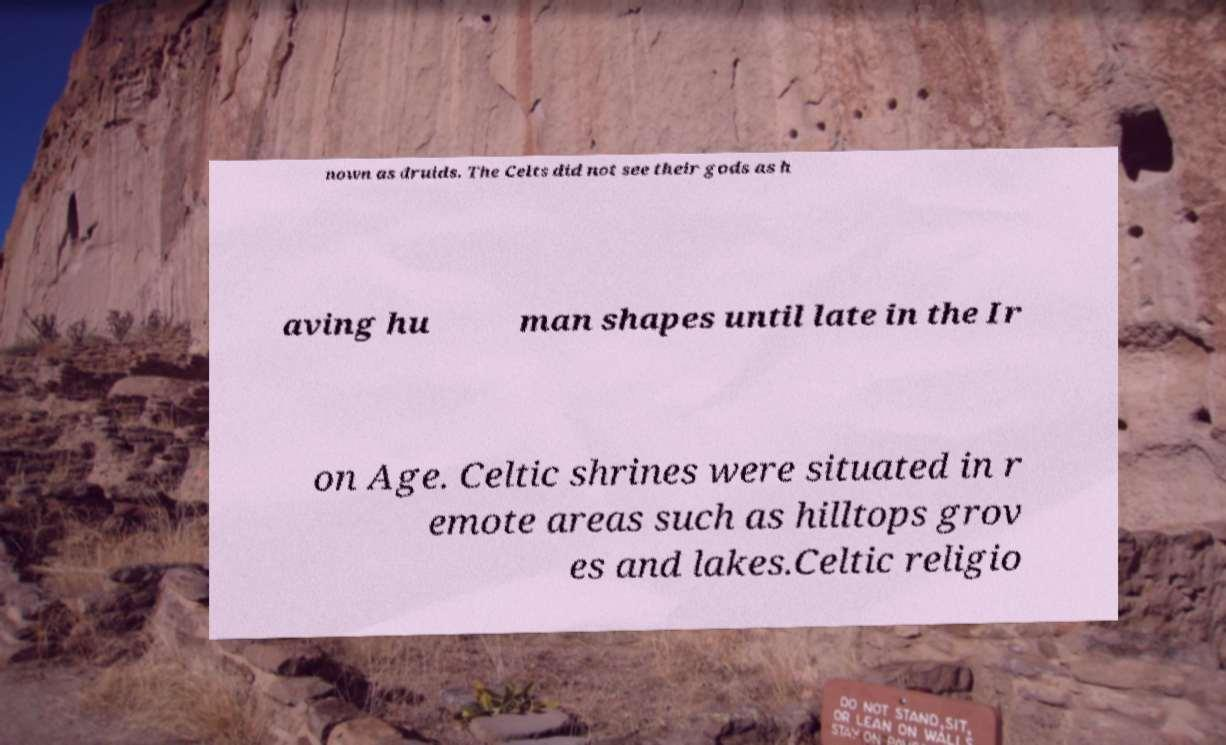For documentation purposes, I need the text within this image transcribed. Could you provide that? nown as druids. The Celts did not see their gods as h aving hu man shapes until late in the Ir on Age. Celtic shrines were situated in r emote areas such as hilltops grov es and lakes.Celtic religio 